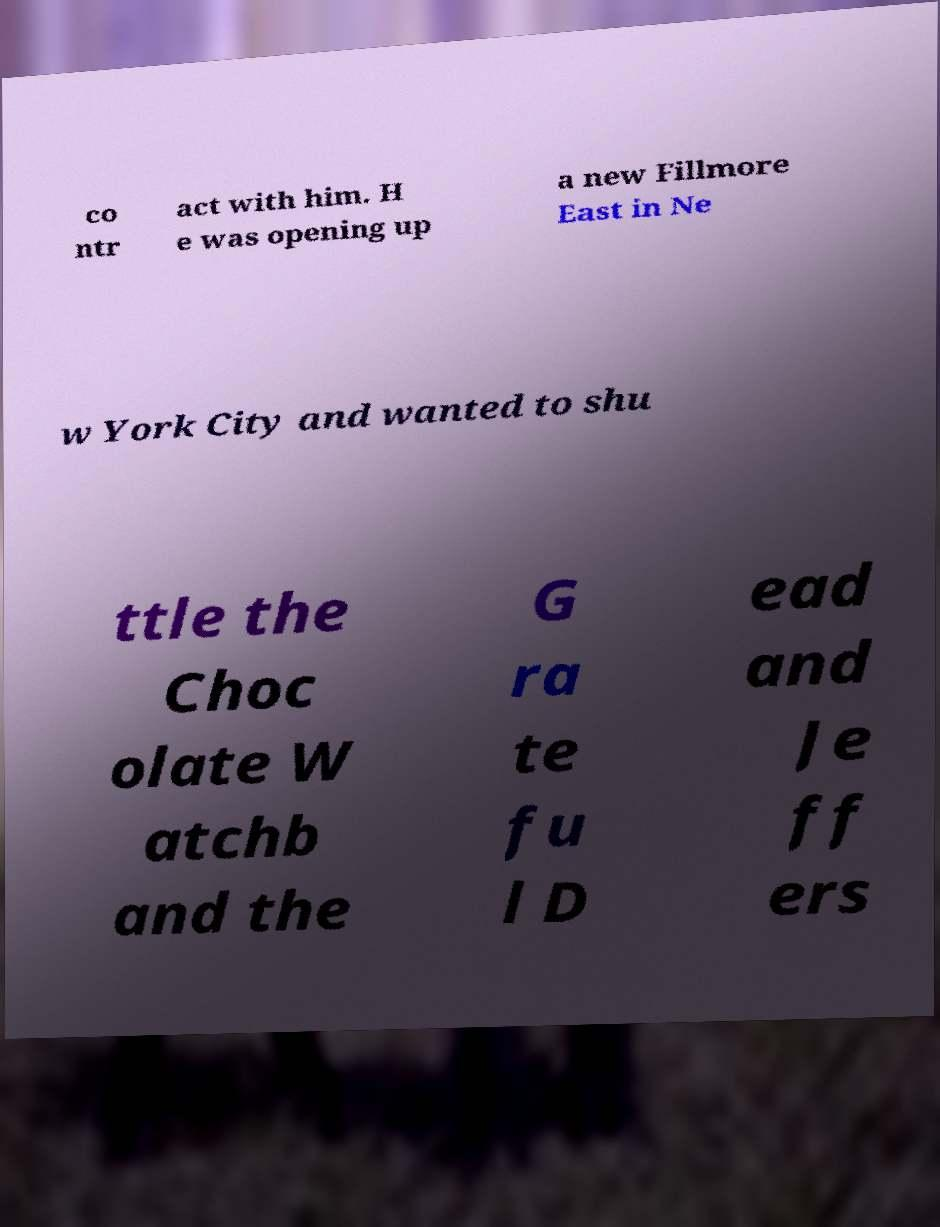Can you accurately transcribe the text from the provided image for me? co ntr act with him. H e was opening up a new Fillmore East in Ne w York City and wanted to shu ttle the Choc olate W atchb and the G ra te fu l D ead and Je ff ers 